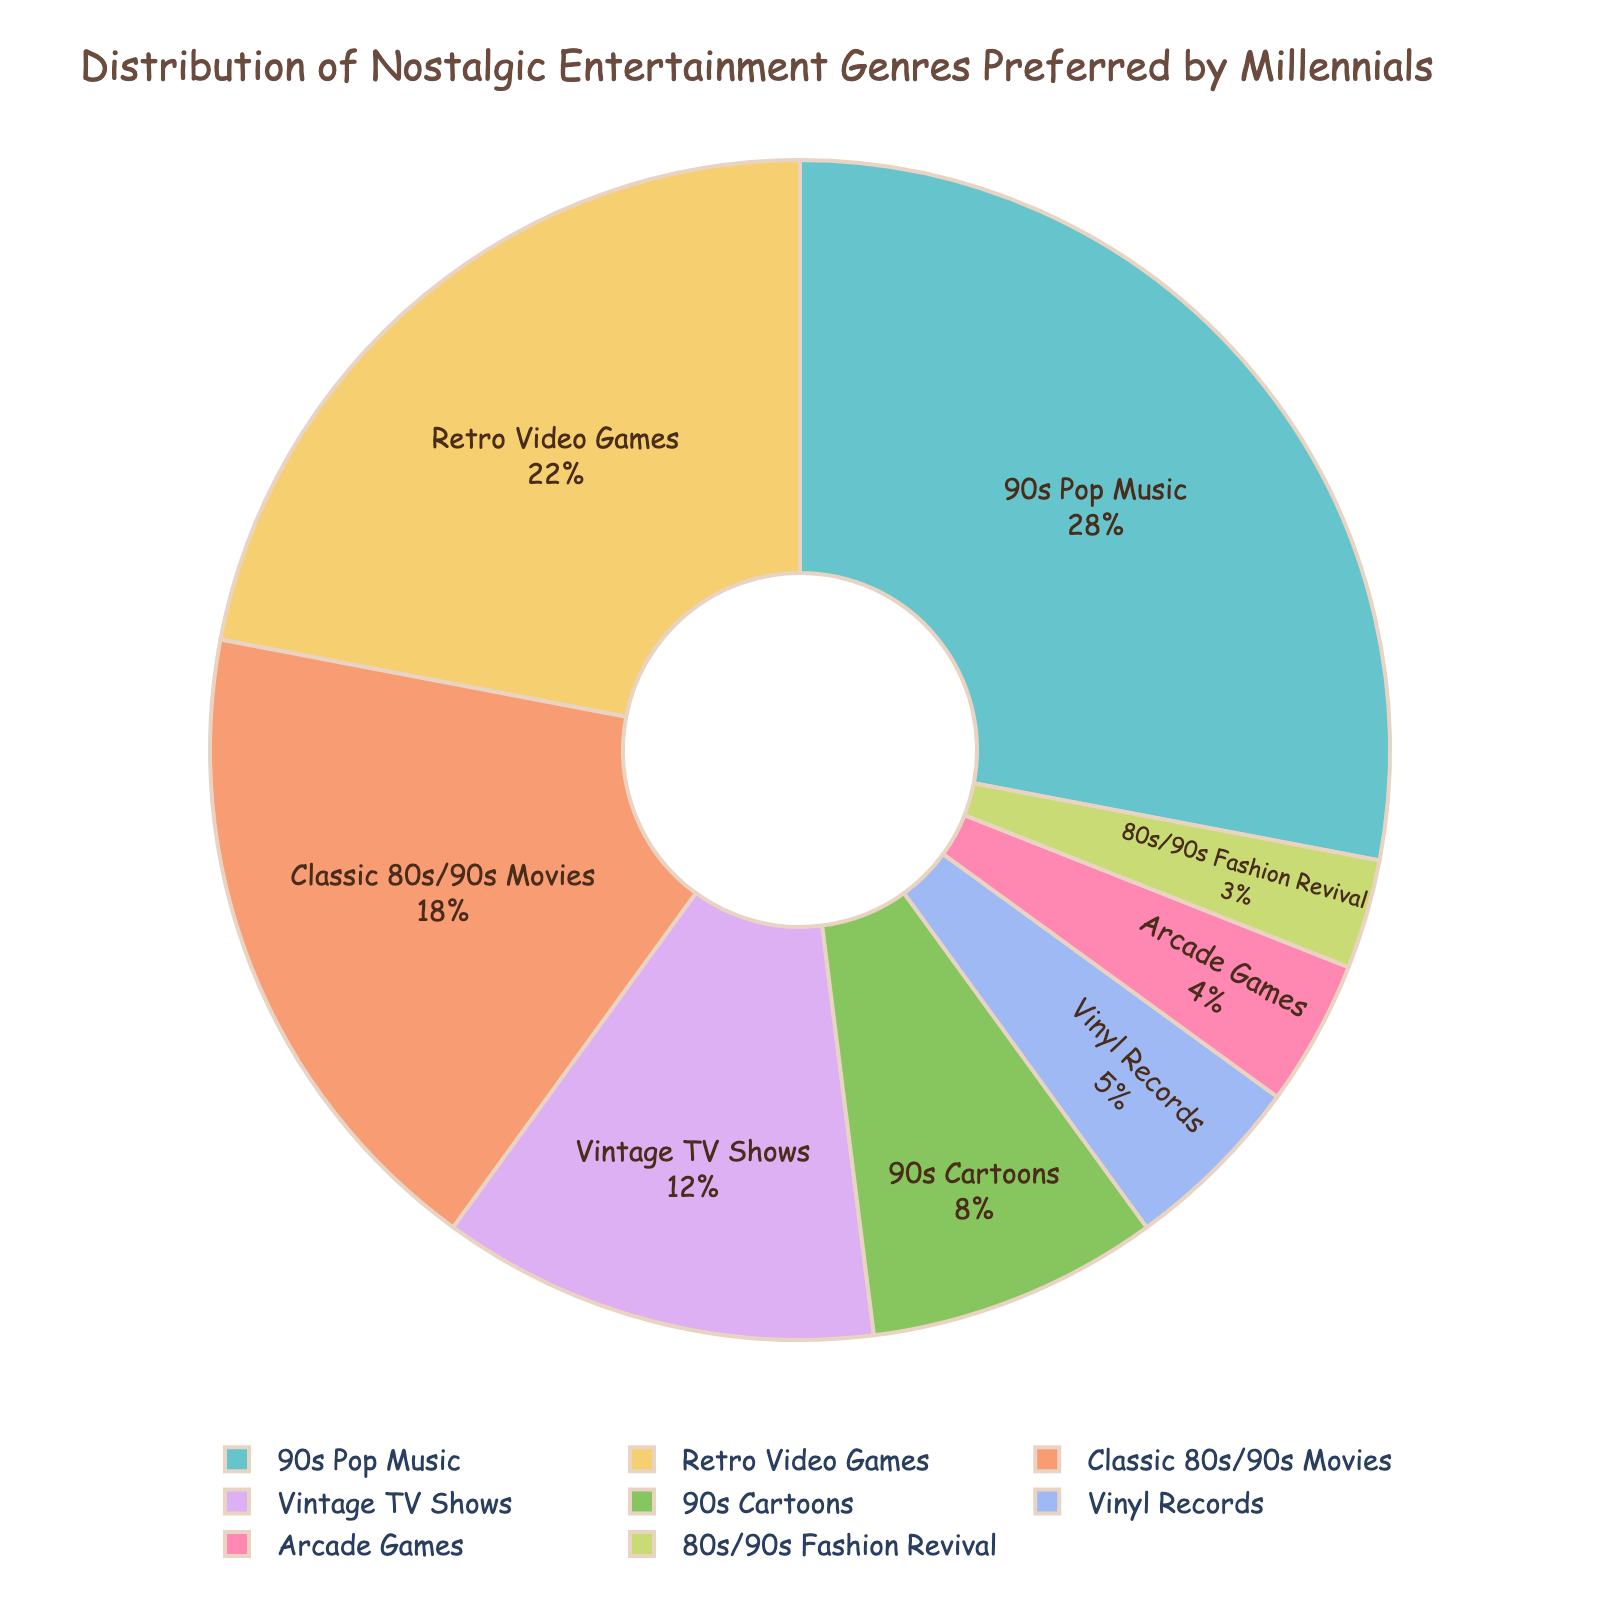What's the most preferred nostalgic entertainment genre among millennials? By looking at the largest segment in the pie chart, we can identify the most preferred genre. The largest slice is attributed to "90s Pop Music" with a larger percentage highlighted.
Answer: 90s Pop Music Which genre is less preferred than "Retro Video Games" but more preferred than "Vintage TV Shows"? First, find the percentage for "Retro Video Games" (22%) and "Vintage TV Shows" (12%). The genre between these percentages is "Classic 80s/90s Movies" with 18%.
Answer: Classic 80s/90s Movies What is the combined preference percentage for "90s Cartoons" and "Vinyl Records"? Locate the percentages for "90s Cartoons" (8%) and "Vinyl Records" (5%) and sum them up: 8 + 5 = 13.
Answer: 13 How does the preference for "Arcade Games" compare to that of "80s/90s Fashion Revival"? Identify the percentages: "Arcade Games" (4%) and "80s/90s Fashion Revival" (3%). Since 4 is greater than 3, "Arcade Games" is more preferred.
Answer: Arcade Games is more preferred Which genres together make up more than 50% of the total preferences? Sum the percentages of the three largest categories until it exceeds 50%: "90s Pop Music" (28%) + "Retro Video Games" (22%) = 50%. Since additional genres are not necessary, only these two make up exactly 50%.
Answer: 90s Pop Music and Retro Video Games What is the total percentage of the top three most preferred nostalgic entertainment genres? Sum the percentages of the top three genres: "90s Pop Music" (28%), "Retro Video Games" (22%), and "Classic 80s/90s Movies" (18%): 28 + 22 + 18 = 68.
Answer: 68 Is the visual representation of "90s Cartoons" larger or smaller than "Vintage TV Shows"? By comparing the sizes of the segments visually, the "90s Cartoons" (8%) segment is seen to be smaller than the "Vintage TV Shows" (12%) segment.
Answer: Smaller Which genre has the smallest preference percentage? Identify the smallest segment in the pie chart. The smallest percentage is "80s/90s Fashion Revival" at 3%.
Answer: 80s/90s Fashion Revival What percentage would you get if you combined "Vintage TV Shows" and "Arcade Games"? Add the percentages for "Vintage TV Shows" (12%) and "Arcade Games" (4%): 12 + 4 = 16.
Answer: 16 